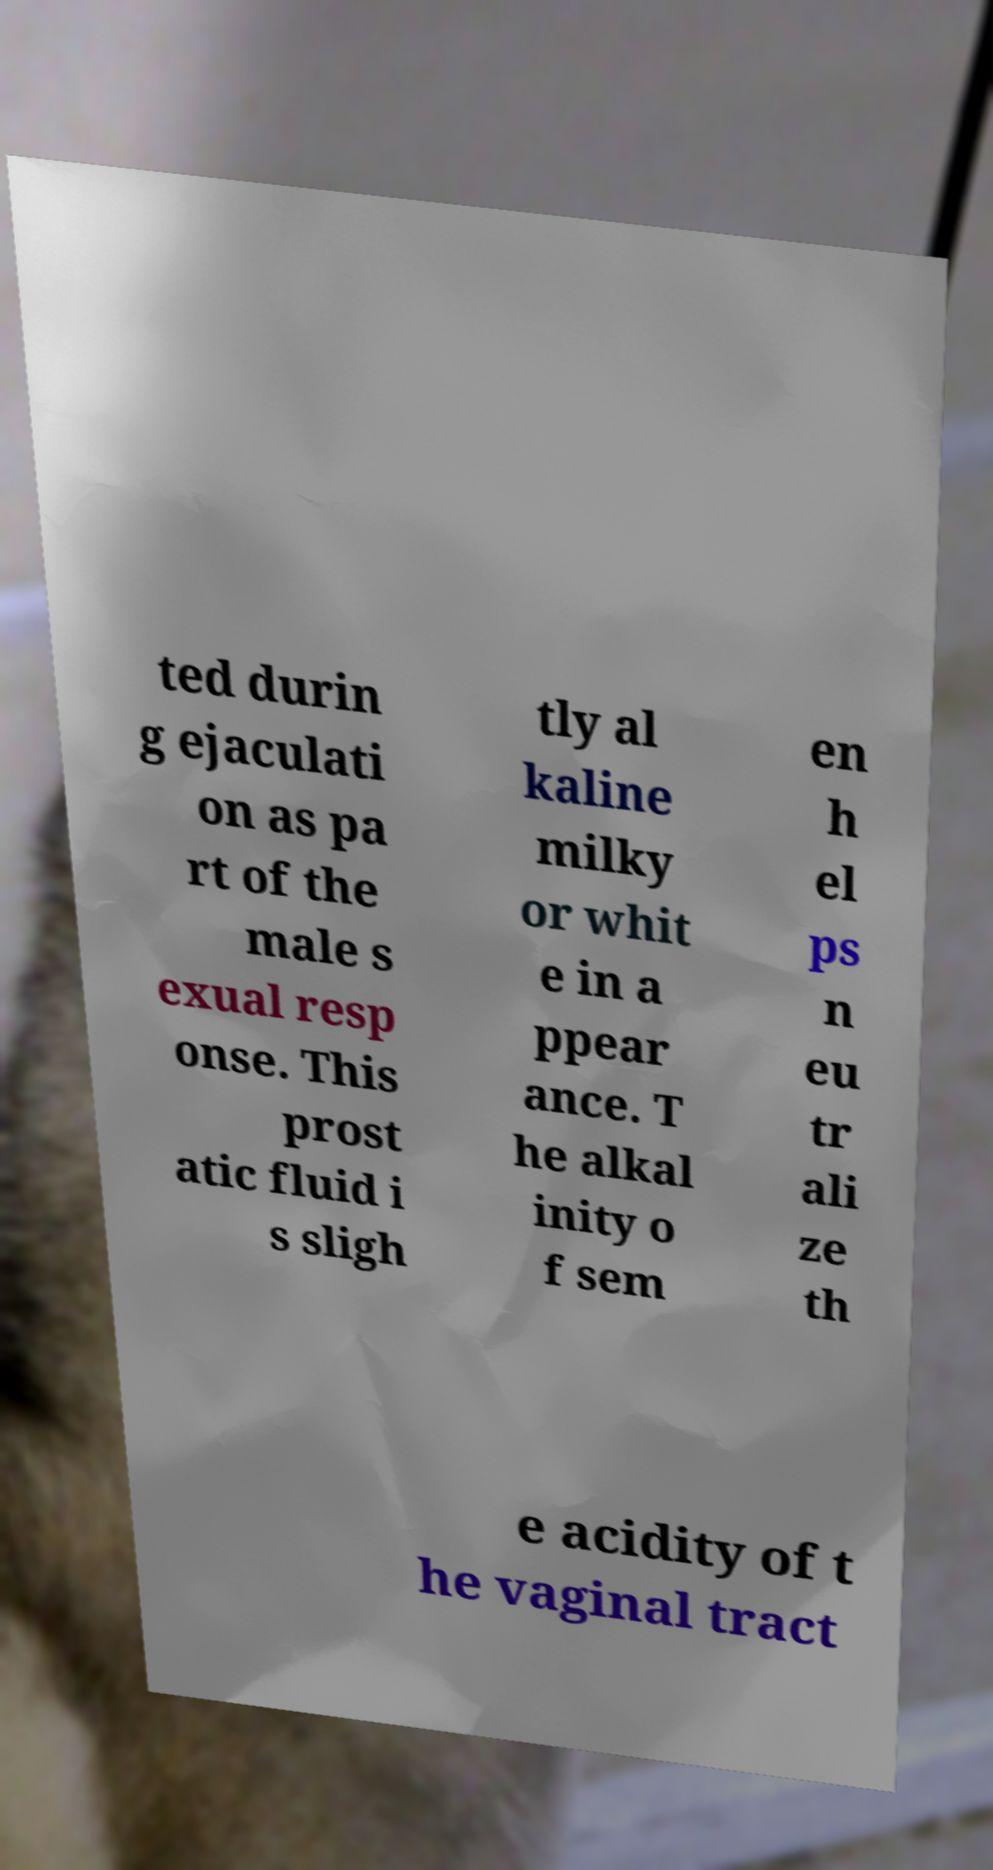Could you assist in decoding the text presented in this image and type it out clearly? ted durin g ejaculati on as pa rt of the male s exual resp onse. This prost atic fluid i s sligh tly al kaline milky or whit e in a ppear ance. T he alkal inity o f sem en h el ps n eu tr ali ze th e acidity of t he vaginal tract 